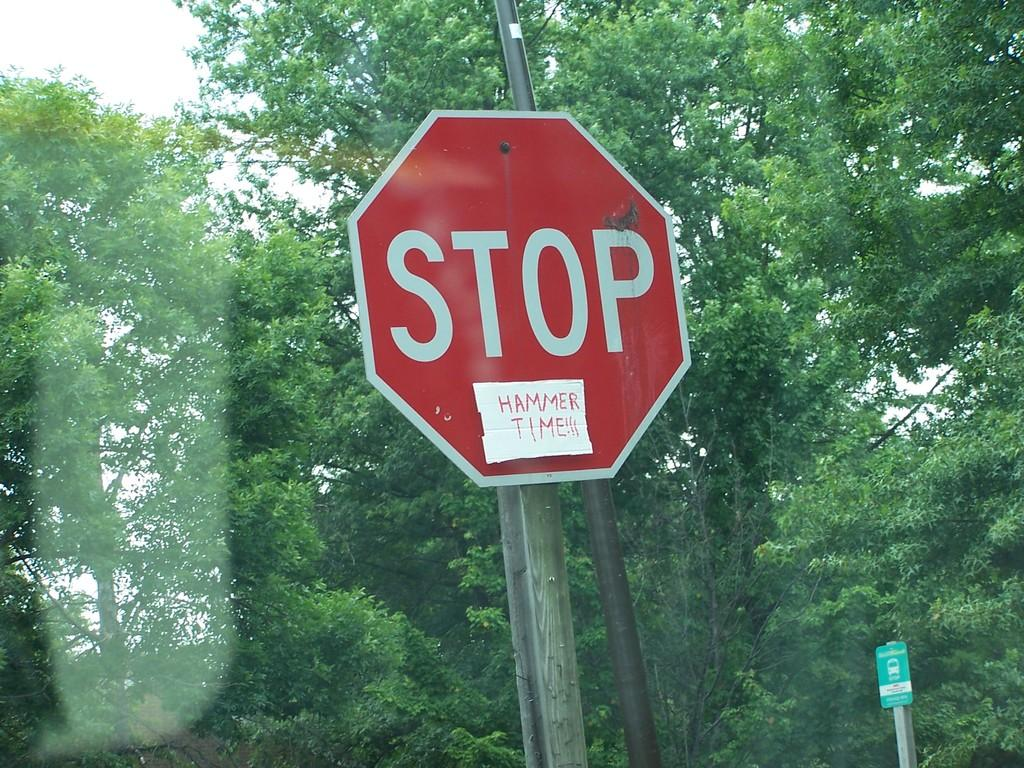Provide a one-sentence caption for the provided image. A stop sign has been altered to say Stop Hammer Time. 